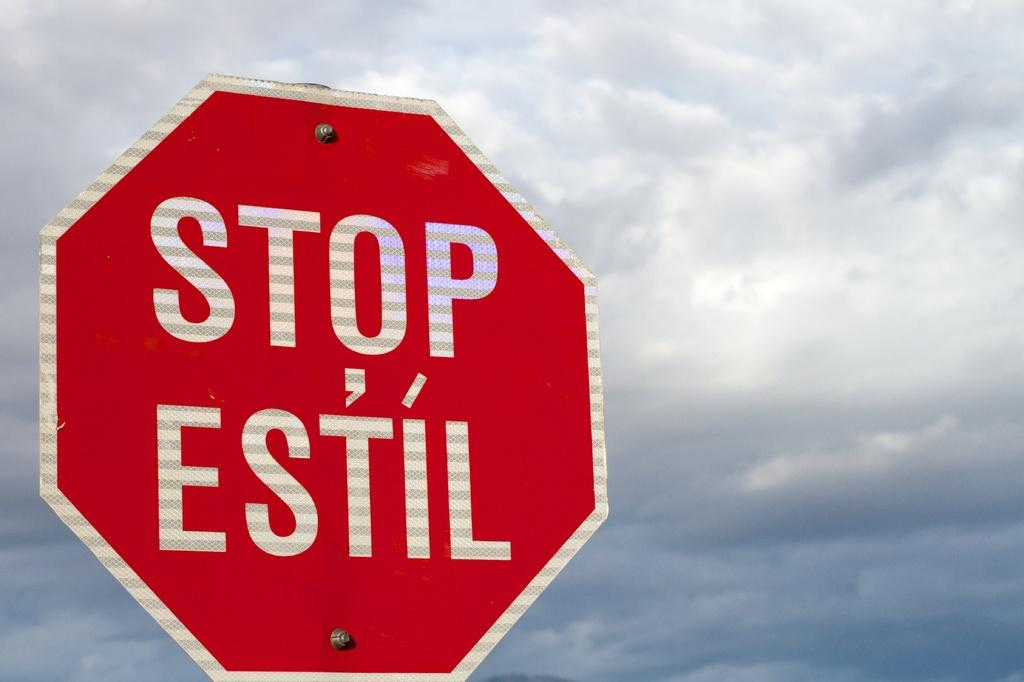Provide a one-sentence caption for the provided image. Stop sign that is wrote in english and estil for spanish. 